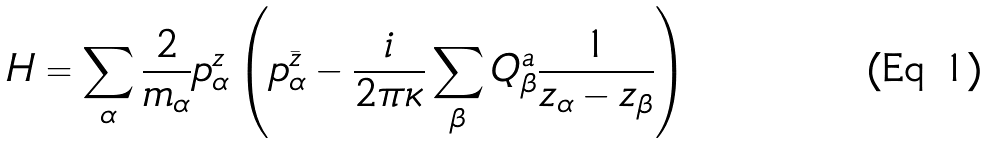Convert formula to latex. <formula><loc_0><loc_0><loc_500><loc_500>H = \sum _ { \alpha } \frac { 2 } { m _ { \alpha } } p _ { \alpha } ^ { z } \left ( p _ { \alpha } ^ { \bar { z } } - { \frac { i } { 2 \pi \kappa } } \sum _ { \beta } Q _ { \beta } ^ { a } { \frac { 1 } { z _ { \alpha } - z _ { \beta } } } \right )</formula> 